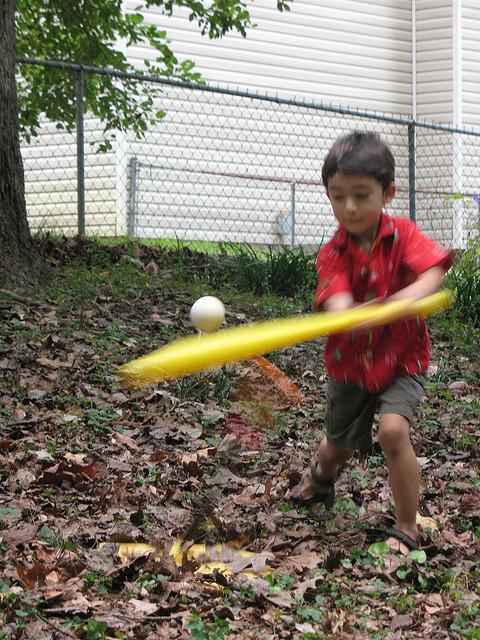What is the boy trying to do?
Concise answer only. Hit ball. What color is his bat?
Answer briefly. Yellow. Have the tree leaves fallen on the ground?
Write a very short answer. Yes. 